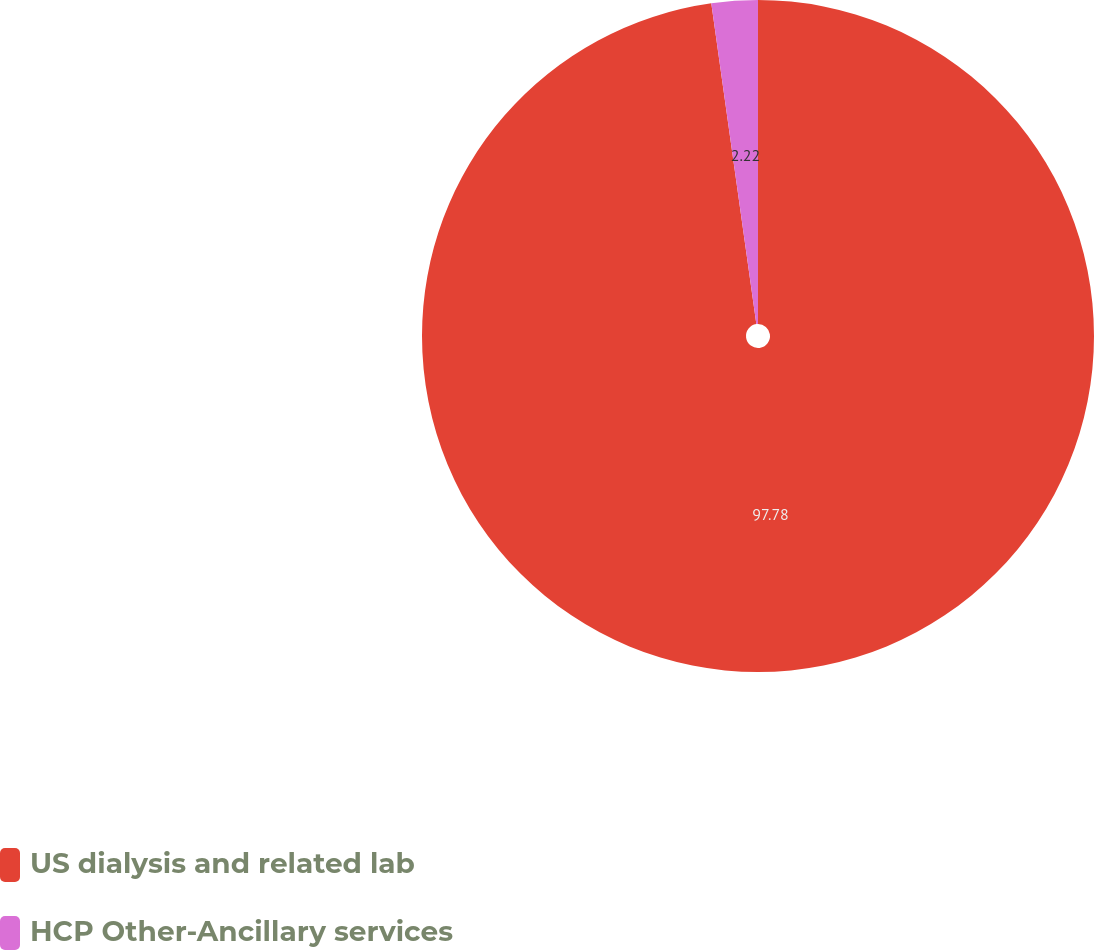Convert chart to OTSL. <chart><loc_0><loc_0><loc_500><loc_500><pie_chart><fcel>US dialysis and related lab<fcel>HCP Other-Ancillary services<nl><fcel>97.78%<fcel>2.22%<nl></chart> 